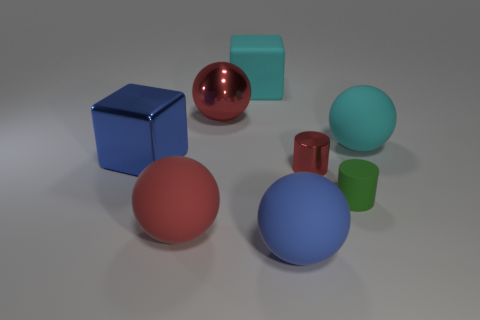What is the relative position of the green cylinder compared to the other objects? The green cylinder is positioned towards the back right side of the image, behind the blue sphere and the red object. It's smaller in size and its matte Surface contrasts with the shinier materials of the nearby shapes. 